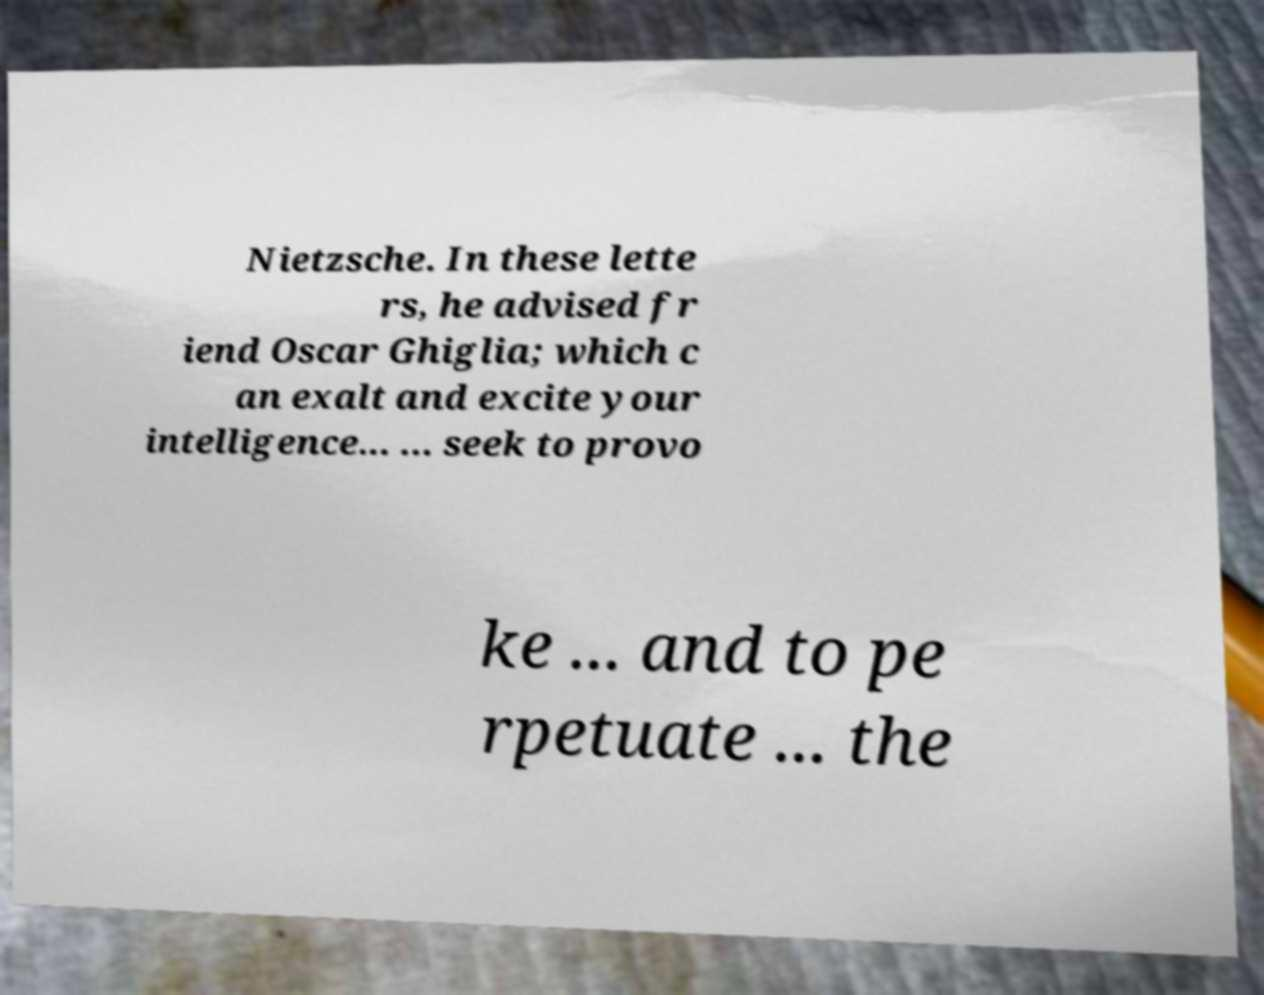Could you extract and type out the text from this image? Nietzsche. In these lette rs, he advised fr iend Oscar Ghiglia; which c an exalt and excite your intelligence... ... seek to provo ke ... and to pe rpetuate ... the 